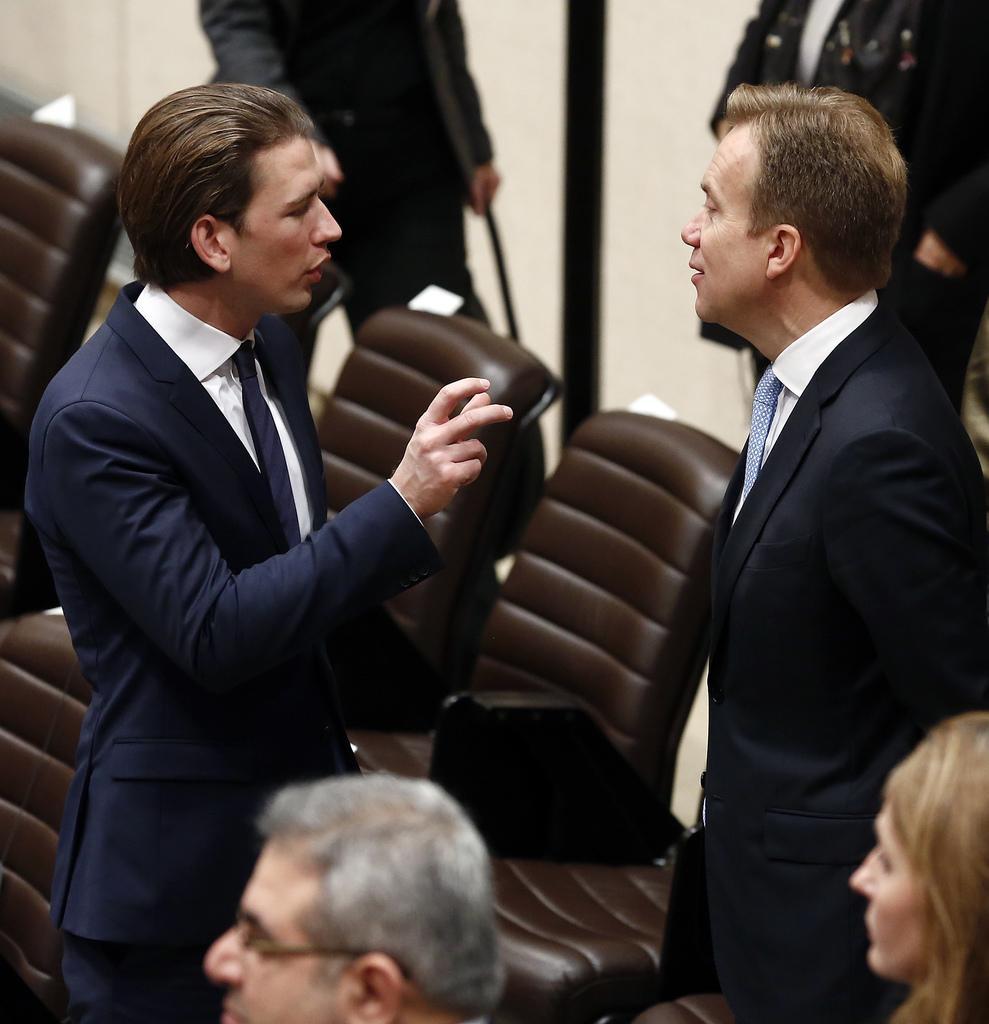Please provide a concise description of this image. This picture shows two men standing and speaking to each other and we see other people standing 